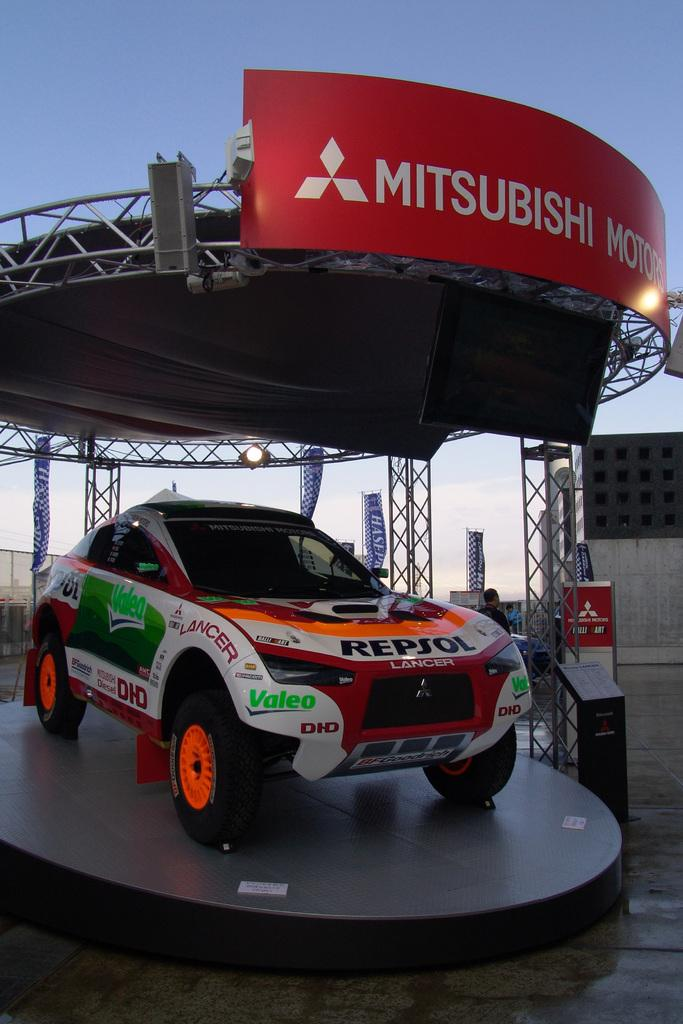What is the main subject of the image? The main subject of the image is a car on a platform. What can be seen in the background of the image? In the background of the image, there is a roof, a person, banners, name boards, a shed, stands, and the sky. Can you describe the car's location in the image? The car is on a platform in the image. What type of lamp is hanging from the car in the image? There is no lamp hanging from the car in the image; it is a car on a platform with various elements visible in the background. 